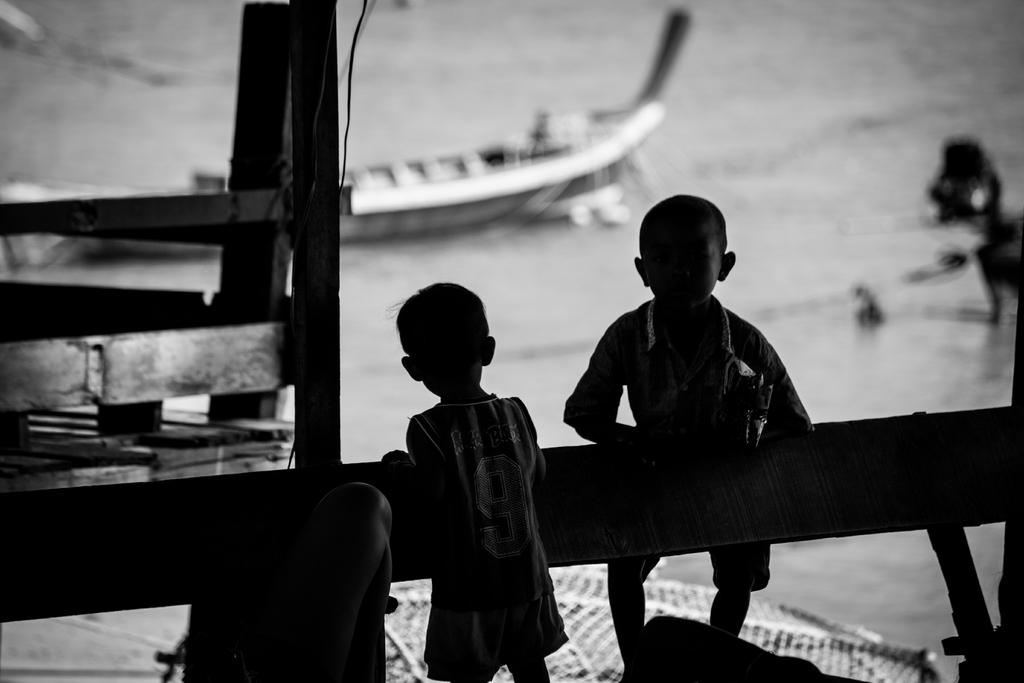What is the lighting condition in the foreground of the image? The foreground of the image is dark. What can be seen in the foreground of the image? There are kids and wooden objects in the foreground. What is visible in the background of the image? There is a water body and a boat in the background. How is the background of the image depicted? The background is blurred. What type of stage can be seen in the image? There is no stage present in the image. Can you describe the view from the stage in the image? There is no stage or view from a stage in the image. 